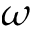Convert formula to latex. <formula><loc_0><loc_0><loc_500><loc_500>\omega</formula> 